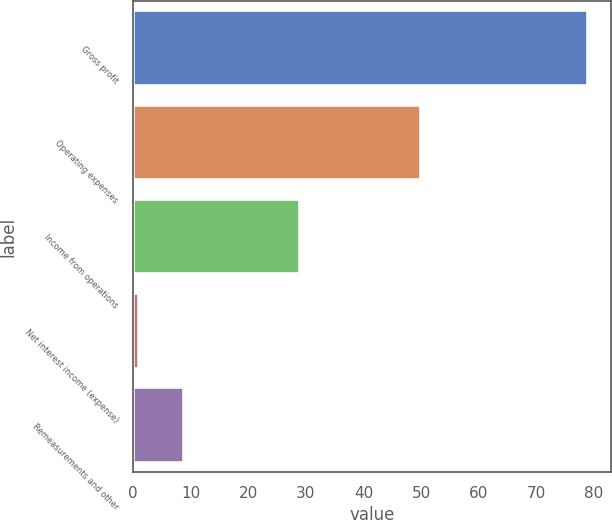Convert chart. <chart><loc_0><loc_0><loc_500><loc_500><bar_chart><fcel>Gross profit<fcel>Operating expenses<fcel>Income from operations<fcel>Net interest income (expense)<fcel>Remeasurements and other<nl><fcel>79<fcel>50<fcel>29<fcel>1<fcel>8.8<nl></chart> 